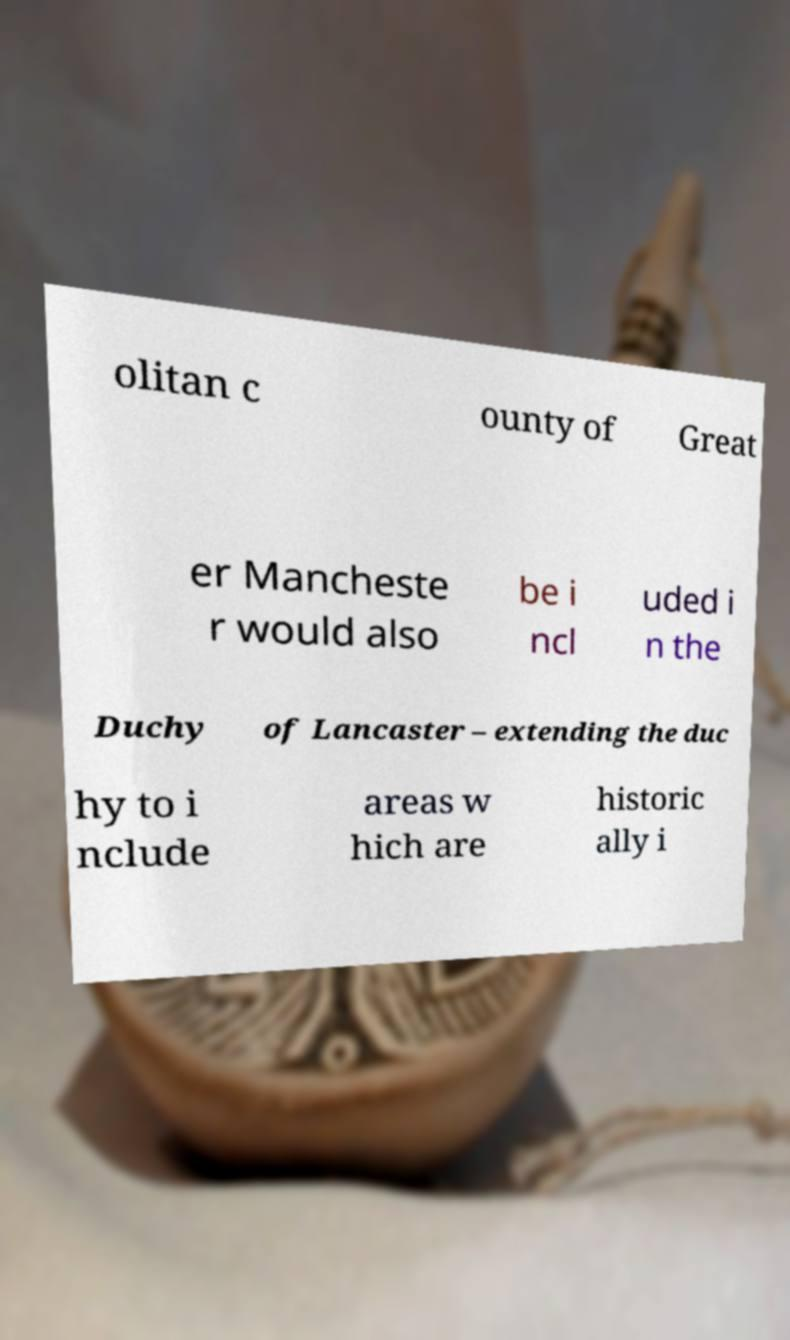Could you assist in decoding the text presented in this image and type it out clearly? olitan c ounty of Great er Mancheste r would also be i ncl uded i n the Duchy of Lancaster – extending the duc hy to i nclude areas w hich are historic ally i 